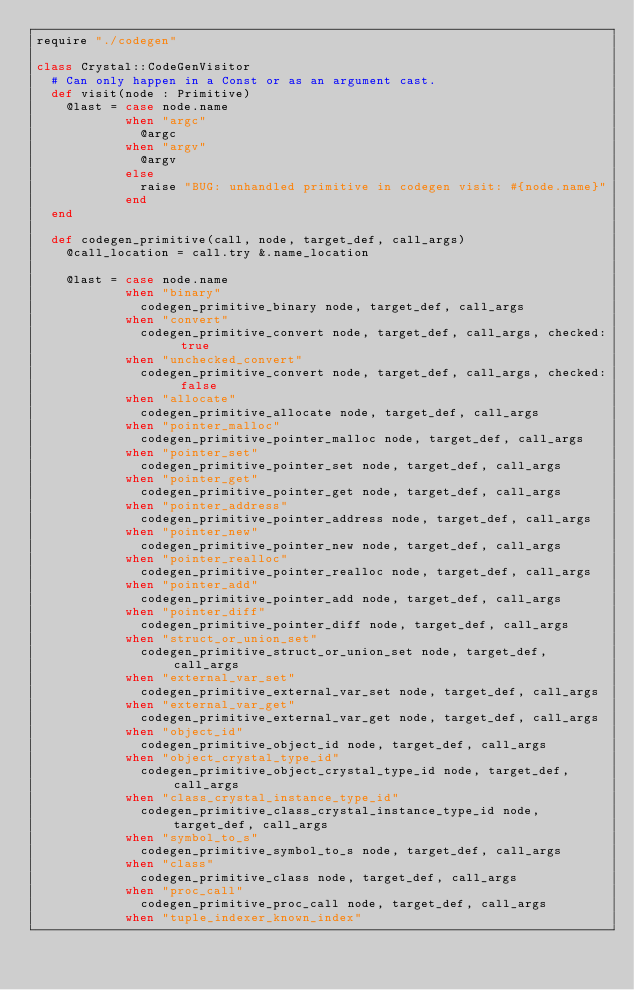Convert code to text. <code><loc_0><loc_0><loc_500><loc_500><_Crystal_>require "./codegen"

class Crystal::CodeGenVisitor
  # Can only happen in a Const or as an argument cast.
  def visit(node : Primitive)
    @last = case node.name
            when "argc"
              @argc
            when "argv"
              @argv
            else
              raise "BUG: unhandled primitive in codegen visit: #{node.name}"
            end
  end

  def codegen_primitive(call, node, target_def, call_args)
    @call_location = call.try &.name_location

    @last = case node.name
            when "binary"
              codegen_primitive_binary node, target_def, call_args
            when "convert"
              codegen_primitive_convert node, target_def, call_args, checked: true
            when "unchecked_convert"
              codegen_primitive_convert node, target_def, call_args, checked: false
            when "allocate"
              codegen_primitive_allocate node, target_def, call_args
            when "pointer_malloc"
              codegen_primitive_pointer_malloc node, target_def, call_args
            when "pointer_set"
              codegen_primitive_pointer_set node, target_def, call_args
            when "pointer_get"
              codegen_primitive_pointer_get node, target_def, call_args
            when "pointer_address"
              codegen_primitive_pointer_address node, target_def, call_args
            when "pointer_new"
              codegen_primitive_pointer_new node, target_def, call_args
            when "pointer_realloc"
              codegen_primitive_pointer_realloc node, target_def, call_args
            when "pointer_add"
              codegen_primitive_pointer_add node, target_def, call_args
            when "pointer_diff"
              codegen_primitive_pointer_diff node, target_def, call_args
            when "struct_or_union_set"
              codegen_primitive_struct_or_union_set node, target_def, call_args
            when "external_var_set"
              codegen_primitive_external_var_set node, target_def, call_args
            when "external_var_get"
              codegen_primitive_external_var_get node, target_def, call_args
            when "object_id"
              codegen_primitive_object_id node, target_def, call_args
            when "object_crystal_type_id"
              codegen_primitive_object_crystal_type_id node, target_def, call_args
            when "class_crystal_instance_type_id"
              codegen_primitive_class_crystal_instance_type_id node, target_def, call_args
            when "symbol_to_s"
              codegen_primitive_symbol_to_s node, target_def, call_args
            when "class"
              codegen_primitive_class node, target_def, call_args
            when "proc_call"
              codegen_primitive_proc_call node, target_def, call_args
            when "tuple_indexer_known_index"</code> 